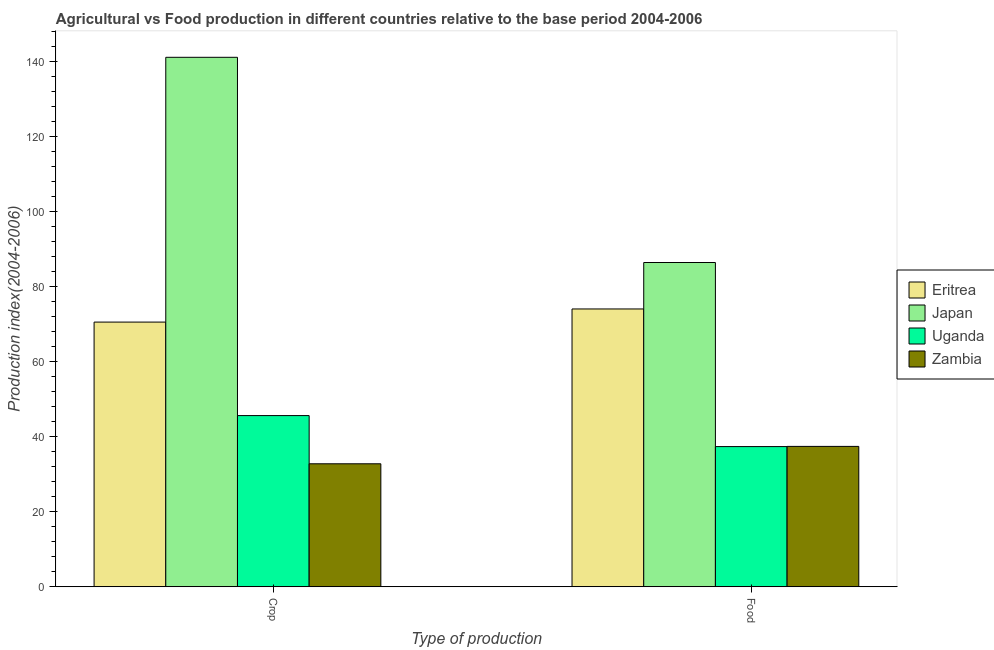How many different coloured bars are there?
Your response must be concise. 4. How many groups of bars are there?
Your response must be concise. 2. How many bars are there on the 1st tick from the left?
Your answer should be very brief. 4. What is the label of the 1st group of bars from the left?
Make the answer very short. Crop. What is the crop production index in Eritrea?
Make the answer very short. 70.6. Across all countries, what is the maximum food production index?
Give a very brief answer. 86.49. Across all countries, what is the minimum food production index?
Offer a terse response. 37.39. In which country was the food production index maximum?
Give a very brief answer. Japan. In which country was the food production index minimum?
Your answer should be very brief. Uganda. What is the total crop production index in the graph?
Keep it short and to the point. 290.29. What is the difference between the crop production index in Uganda and that in Zambia?
Your answer should be very brief. 12.86. What is the difference between the food production index in Eritrea and the crop production index in Zambia?
Keep it short and to the point. 41.3. What is the average crop production index per country?
Your response must be concise. 72.57. In how many countries, is the crop production index greater than 76 ?
Your answer should be very brief. 1. What is the ratio of the food production index in Eritrea to that in Uganda?
Make the answer very short. 1.98. Is the food production index in Zambia less than that in Uganda?
Your answer should be very brief. No. In how many countries, is the crop production index greater than the average crop production index taken over all countries?
Keep it short and to the point. 1. What does the 3rd bar from the left in Food represents?
Your answer should be compact. Uganda. What does the 4th bar from the right in Crop represents?
Your answer should be compact. Eritrea. How many countries are there in the graph?
Your answer should be very brief. 4. Where does the legend appear in the graph?
Make the answer very short. Center right. How many legend labels are there?
Keep it short and to the point. 4. What is the title of the graph?
Keep it short and to the point. Agricultural vs Food production in different countries relative to the base period 2004-2006. What is the label or title of the X-axis?
Provide a short and direct response. Type of production. What is the label or title of the Y-axis?
Give a very brief answer. Production index(2004-2006). What is the Production index(2004-2006) of Eritrea in Crop?
Make the answer very short. 70.6. What is the Production index(2004-2006) of Japan in Crop?
Provide a succinct answer. 141.23. What is the Production index(2004-2006) of Uganda in Crop?
Provide a short and direct response. 45.66. What is the Production index(2004-2006) in Zambia in Crop?
Give a very brief answer. 32.8. What is the Production index(2004-2006) of Eritrea in Food?
Keep it short and to the point. 74.1. What is the Production index(2004-2006) of Japan in Food?
Give a very brief answer. 86.49. What is the Production index(2004-2006) of Uganda in Food?
Your answer should be compact. 37.39. What is the Production index(2004-2006) in Zambia in Food?
Your response must be concise. 37.44. Across all Type of production, what is the maximum Production index(2004-2006) in Eritrea?
Give a very brief answer. 74.1. Across all Type of production, what is the maximum Production index(2004-2006) of Japan?
Offer a terse response. 141.23. Across all Type of production, what is the maximum Production index(2004-2006) of Uganda?
Give a very brief answer. 45.66. Across all Type of production, what is the maximum Production index(2004-2006) in Zambia?
Your answer should be compact. 37.44. Across all Type of production, what is the minimum Production index(2004-2006) in Eritrea?
Offer a very short reply. 70.6. Across all Type of production, what is the minimum Production index(2004-2006) of Japan?
Provide a succinct answer. 86.49. Across all Type of production, what is the minimum Production index(2004-2006) of Uganda?
Provide a succinct answer. 37.39. Across all Type of production, what is the minimum Production index(2004-2006) of Zambia?
Your answer should be compact. 32.8. What is the total Production index(2004-2006) in Eritrea in the graph?
Provide a succinct answer. 144.7. What is the total Production index(2004-2006) of Japan in the graph?
Provide a short and direct response. 227.72. What is the total Production index(2004-2006) in Uganda in the graph?
Your answer should be compact. 83.05. What is the total Production index(2004-2006) in Zambia in the graph?
Your answer should be compact. 70.24. What is the difference between the Production index(2004-2006) of Japan in Crop and that in Food?
Provide a short and direct response. 54.74. What is the difference between the Production index(2004-2006) in Uganda in Crop and that in Food?
Make the answer very short. 8.27. What is the difference between the Production index(2004-2006) of Zambia in Crop and that in Food?
Make the answer very short. -4.64. What is the difference between the Production index(2004-2006) in Eritrea in Crop and the Production index(2004-2006) in Japan in Food?
Your answer should be compact. -15.89. What is the difference between the Production index(2004-2006) of Eritrea in Crop and the Production index(2004-2006) of Uganda in Food?
Ensure brevity in your answer.  33.21. What is the difference between the Production index(2004-2006) in Eritrea in Crop and the Production index(2004-2006) in Zambia in Food?
Your answer should be very brief. 33.16. What is the difference between the Production index(2004-2006) in Japan in Crop and the Production index(2004-2006) in Uganda in Food?
Your response must be concise. 103.84. What is the difference between the Production index(2004-2006) in Japan in Crop and the Production index(2004-2006) in Zambia in Food?
Provide a succinct answer. 103.79. What is the difference between the Production index(2004-2006) in Uganda in Crop and the Production index(2004-2006) in Zambia in Food?
Your answer should be compact. 8.22. What is the average Production index(2004-2006) in Eritrea per Type of production?
Offer a very short reply. 72.35. What is the average Production index(2004-2006) in Japan per Type of production?
Provide a succinct answer. 113.86. What is the average Production index(2004-2006) in Uganda per Type of production?
Your response must be concise. 41.52. What is the average Production index(2004-2006) of Zambia per Type of production?
Your answer should be very brief. 35.12. What is the difference between the Production index(2004-2006) in Eritrea and Production index(2004-2006) in Japan in Crop?
Provide a short and direct response. -70.63. What is the difference between the Production index(2004-2006) of Eritrea and Production index(2004-2006) of Uganda in Crop?
Offer a very short reply. 24.94. What is the difference between the Production index(2004-2006) in Eritrea and Production index(2004-2006) in Zambia in Crop?
Keep it short and to the point. 37.8. What is the difference between the Production index(2004-2006) in Japan and Production index(2004-2006) in Uganda in Crop?
Provide a succinct answer. 95.57. What is the difference between the Production index(2004-2006) of Japan and Production index(2004-2006) of Zambia in Crop?
Provide a short and direct response. 108.43. What is the difference between the Production index(2004-2006) of Uganda and Production index(2004-2006) of Zambia in Crop?
Offer a terse response. 12.86. What is the difference between the Production index(2004-2006) of Eritrea and Production index(2004-2006) of Japan in Food?
Provide a short and direct response. -12.39. What is the difference between the Production index(2004-2006) in Eritrea and Production index(2004-2006) in Uganda in Food?
Give a very brief answer. 36.71. What is the difference between the Production index(2004-2006) in Eritrea and Production index(2004-2006) in Zambia in Food?
Make the answer very short. 36.66. What is the difference between the Production index(2004-2006) of Japan and Production index(2004-2006) of Uganda in Food?
Your answer should be very brief. 49.1. What is the difference between the Production index(2004-2006) in Japan and Production index(2004-2006) in Zambia in Food?
Offer a terse response. 49.05. What is the ratio of the Production index(2004-2006) in Eritrea in Crop to that in Food?
Offer a terse response. 0.95. What is the ratio of the Production index(2004-2006) in Japan in Crop to that in Food?
Make the answer very short. 1.63. What is the ratio of the Production index(2004-2006) of Uganda in Crop to that in Food?
Keep it short and to the point. 1.22. What is the ratio of the Production index(2004-2006) of Zambia in Crop to that in Food?
Make the answer very short. 0.88. What is the difference between the highest and the second highest Production index(2004-2006) in Japan?
Your answer should be very brief. 54.74. What is the difference between the highest and the second highest Production index(2004-2006) in Uganda?
Offer a very short reply. 8.27. What is the difference between the highest and the second highest Production index(2004-2006) in Zambia?
Your answer should be compact. 4.64. What is the difference between the highest and the lowest Production index(2004-2006) of Japan?
Your answer should be very brief. 54.74. What is the difference between the highest and the lowest Production index(2004-2006) in Uganda?
Provide a short and direct response. 8.27. What is the difference between the highest and the lowest Production index(2004-2006) of Zambia?
Give a very brief answer. 4.64. 